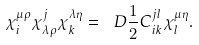<formula> <loc_0><loc_0><loc_500><loc_500>\chi _ { i } ^ { \mu \rho } \chi _ { \lambda \rho } ^ { j } \chi _ { k } ^ { \lambda \eta } = \ D { \frac { 1 } { 2 } } C _ { i k } ^ { j l } \chi _ { l } ^ { \mu \eta } .</formula> 